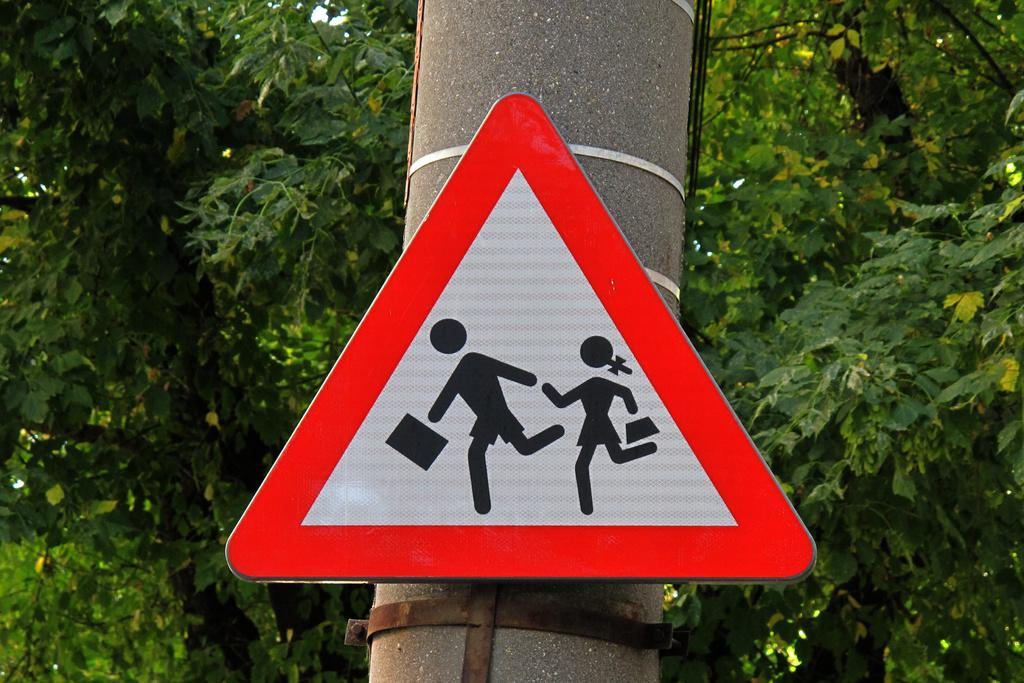What is attached to the pole in the image? There is a signboard attached to a pole in the image. What can be seen in the background of the image? There are trees in the background of the image. How does the comb help the arch in the image? There is no comb or arch present in the image; the image only features a signboard attached to a pole and trees in the background. 